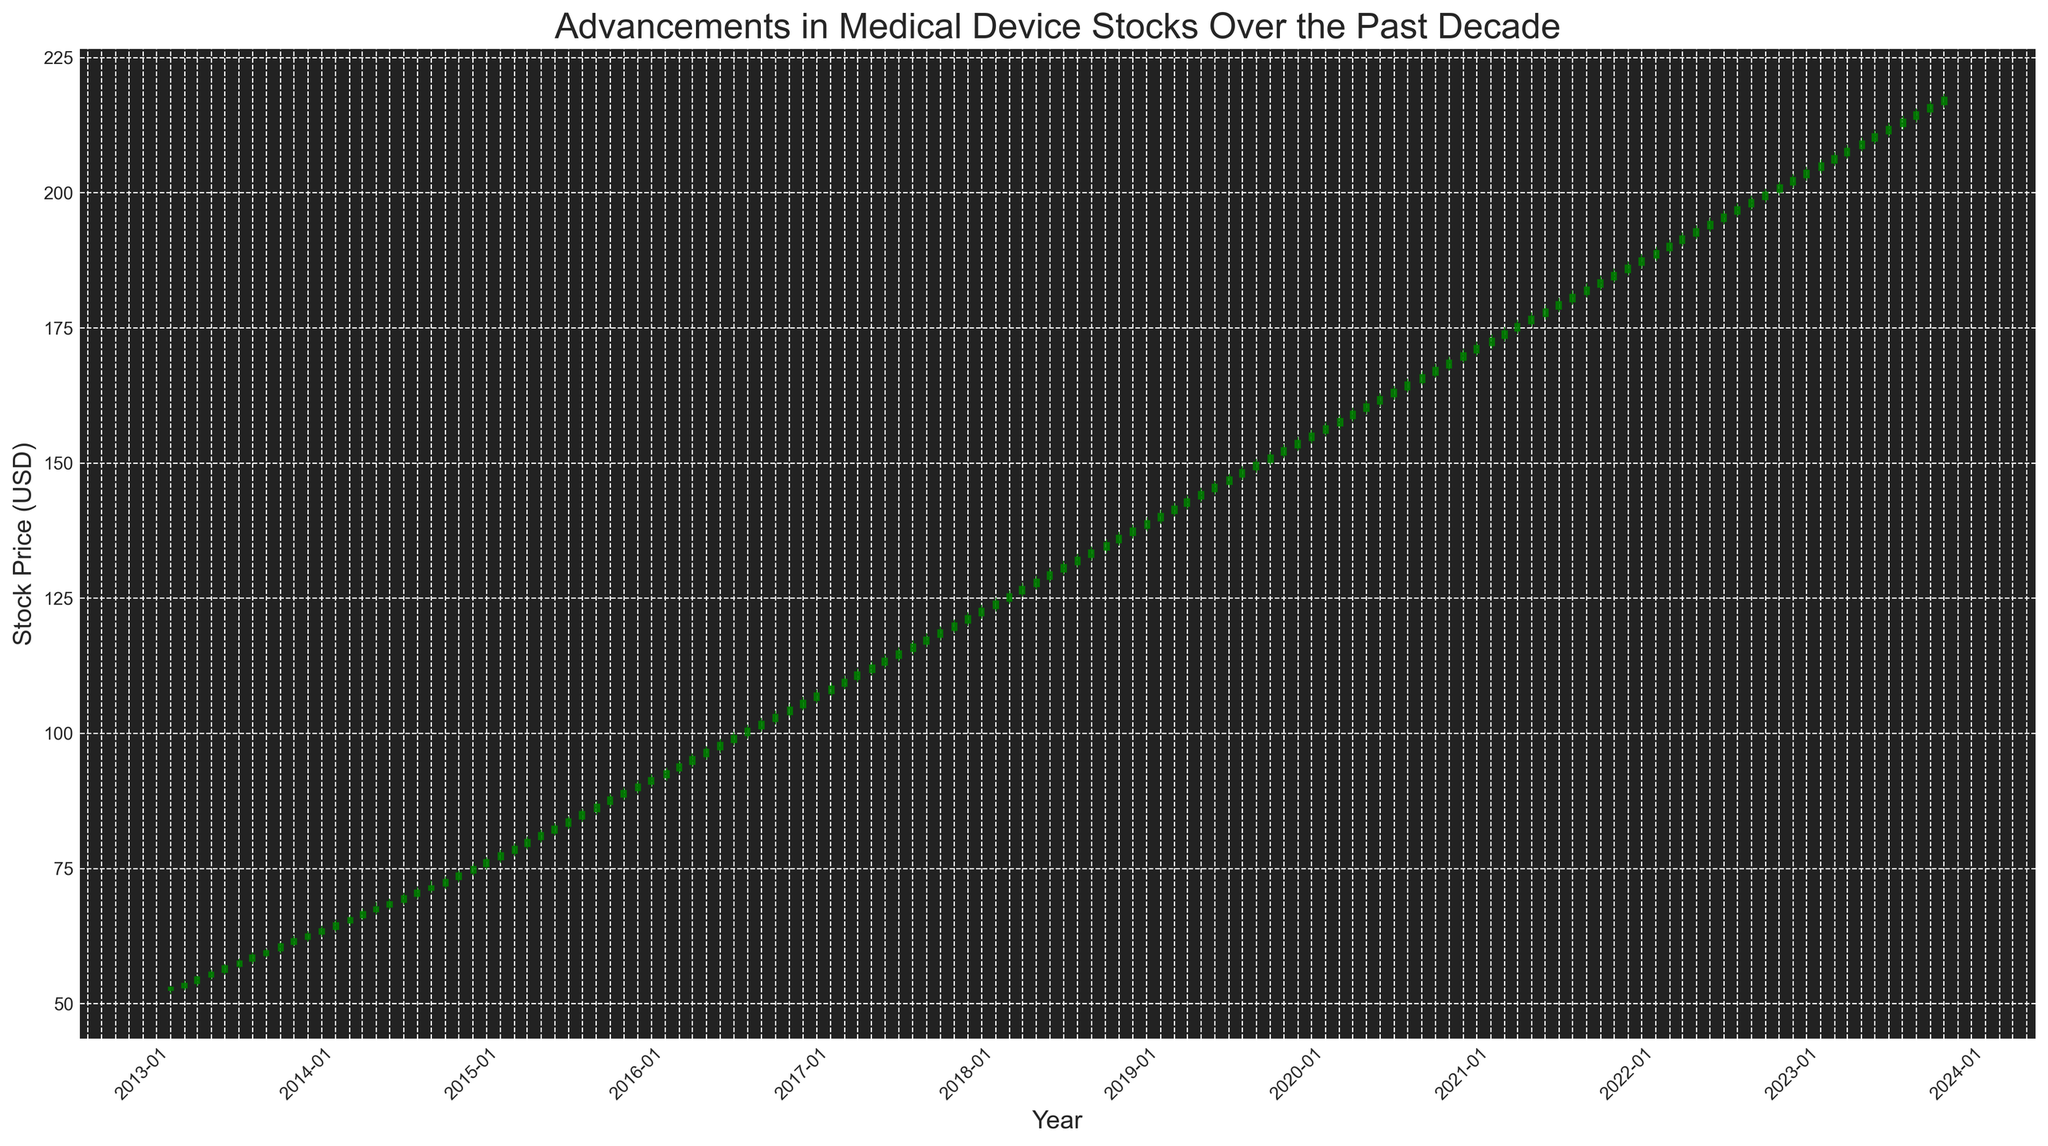What's the overall trend in the stock prices from 2013 to 2023? The overall trend can be observed by noting the general direction of the candlesticks from the starting point (2013) to the end point (2023). The candlesticks generally move upwards, indicating an increase in stock prices over the decade.
Answer: Upward trend Which year saw the highest number of red candlesticks? To determine the year with the highest number of red candlesticks, count the red candlesticks (declining months) in each year by visually inspecting the color of the candlesticks. One way to observe this is to see if there are frequent sequences of red candlesticks within a particular year.
Answer: 2013 In which year did the stock price experience the greatest increase from the start to the end of the year? Look for the year where the starting candlestick (January) has a significantly lower bottom compared to the ending candlestick (December). Calculate the difference between the closing price of December and the opening price of January for each year to identify the year with the greatest increase.
Answer: 2019 Compare the stock price trends between 2016 and 2020. Which period had a steeper increase in stock prices? Evaluate the slope formed by connecting the starting and ending points of each period (2016 and 2020). Observe whether the stock prices increased more steeply from 2016 to 2020 or from 2020 onward.
Answer: 2016-2020 What was the lowest opening stock price within the decade, and in which month and year did it occur? Identify the lowest opening price by examining each candlestick's opening value. The lowest-level starting point at the bottom half of any green or red candlestick corresponds to the lowest opening stock price.
Answer: January 2013 Between 2017 and 2018, in which specific month did the stock price make its largest single-month leap? Look for the candlestick with the longest body, indicating a large difference between the opening and closing prices, within the 2017-2018 range. This candlestick will show a significant change within that period.
Answer: January 2018 During the decade, which year had the most upward-trending months (green candlesticks)? By counting the green candlesticks for each year, you can determine which year has the most positive months where the closing price was higher than the opening price.
Answer: 2023 What is the average closing stock price for the entire decade? Add up all the closing prices from each month and divide by the total number of months (120).
Answer: 135.15 Identify the month and year that experienced the sharpest drop in stock price within one month. Locate the longest red candlestick, signifying the largest decrease from opening to closing price in a single period throughout the decade.
Answer: October 2013 